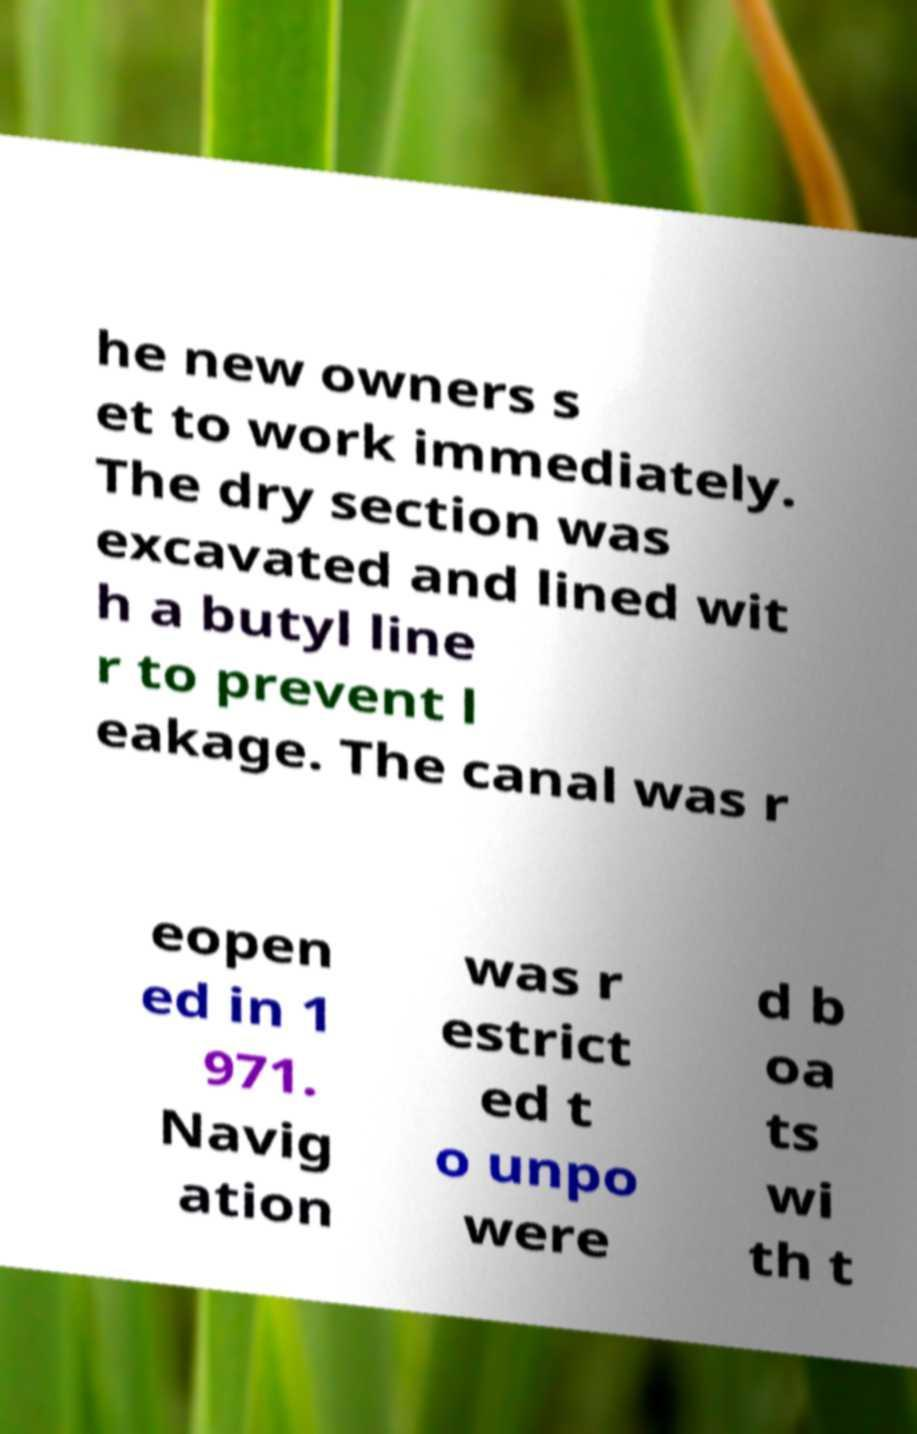Can you read and provide the text displayed in the image?This photo seems to have some interesting text. Can you extract and type it out for me? he new owners s et to work immediately. The dry section was excavated and lined wit h a butyl line r to prevent l eakage. The canal was r eopen ed in 1 971. Navig ation was r estrict ed t o unpo were d b oa ts wi th t 